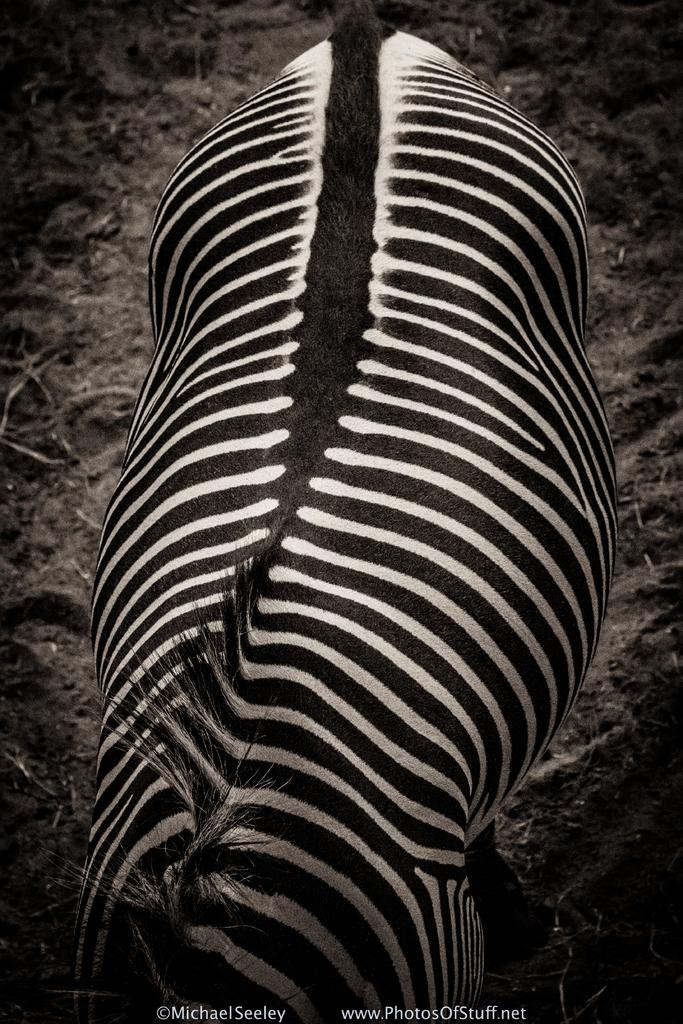What is the color scheme of the image? The image is black and white. What animal is featured in the image? There is a zebra in the image. How is the image presented? The image is truncated. What can be found at the bottom of the image? There is text at the bottom of the image. How many bells are hanging from the zebra's neck in the image? There are no bells present in the image; it only features a zebra. What type of bucket can be seen in the image? There is no bucket present in the image. 